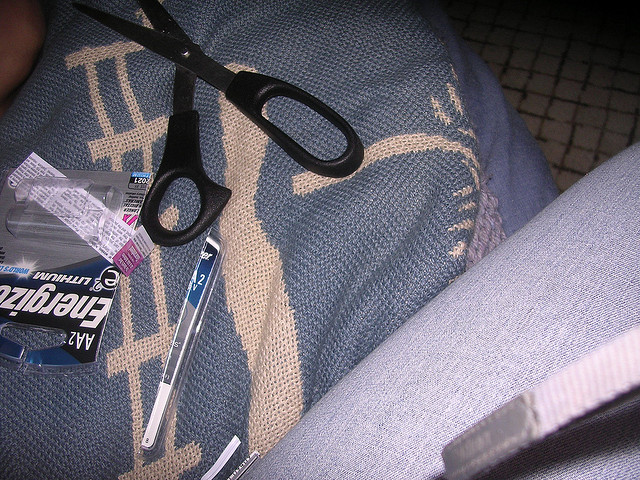<image>What is the battery package type? I don't know the battery package type. It can be 'aa', 'energizer' or 'plastic'. What is the battery package type? I don't know what is the battery package type. It can be either AA or Energizer. 